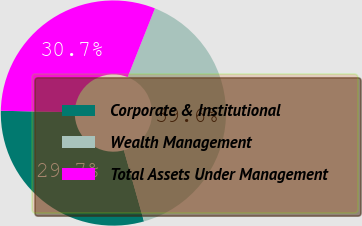<chart> <loc_0><loc_0><loc_500><loc_500><pie_chart><fcel>Corporate & Institutional<fcel>Wealth Management<fcel>Total Assets Under Management<nl><fcel>29.7%<fcel>39.6%<fcel>30.69%<nl></chart> 